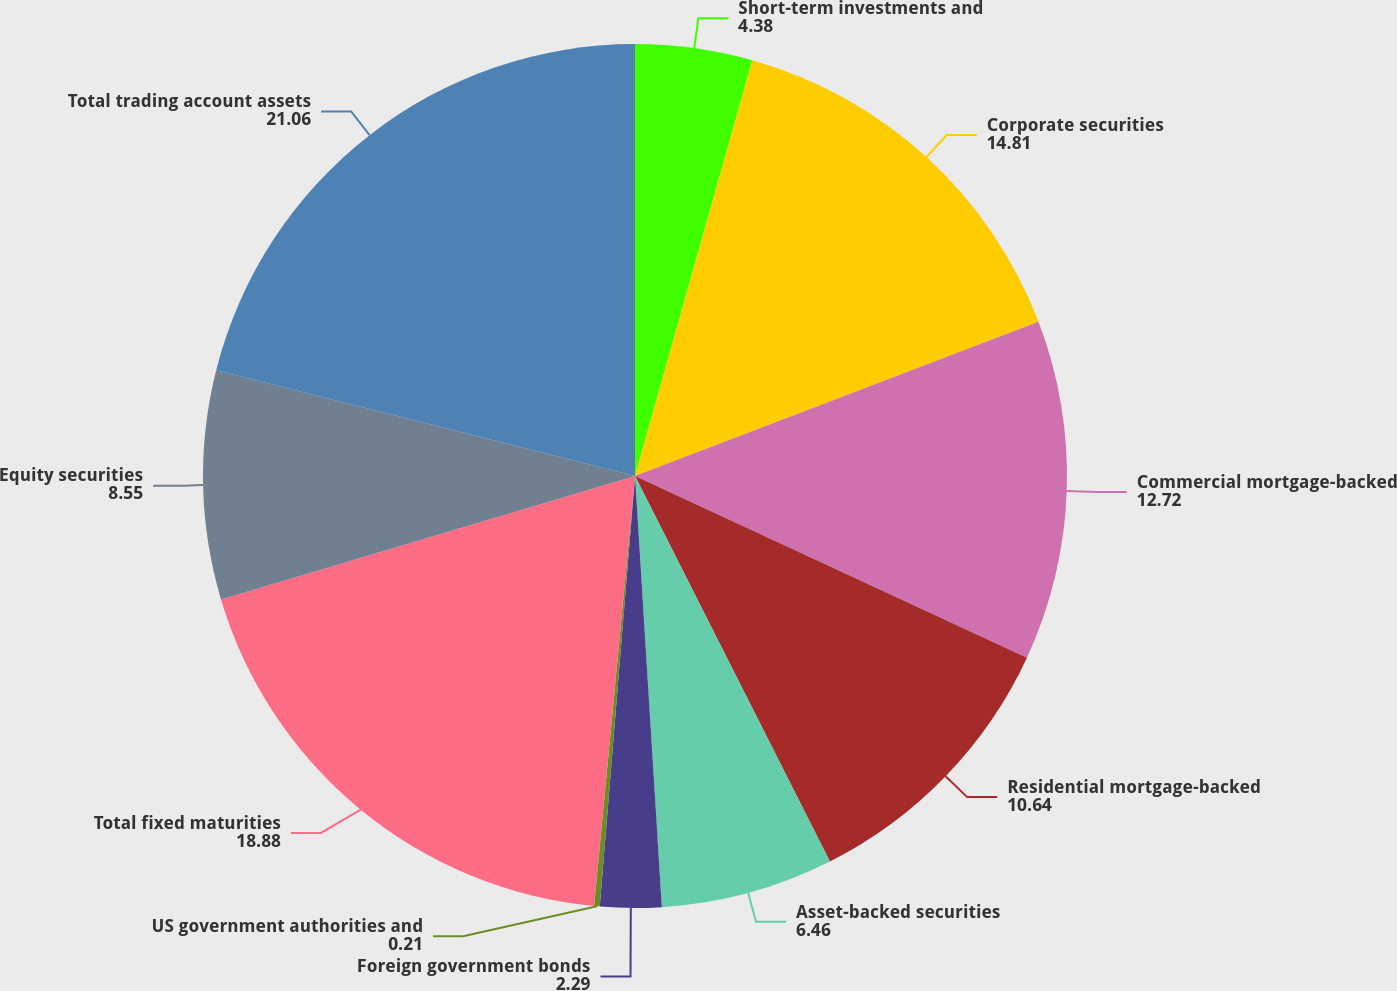Convert chart to OTSL. <chart><loc_0><loc_0><loc_500><loc_500><pie_chart><fcel>Short-term investments and<fcel>Corporate securities<fcel>Commercial mortgage-backed<fcel>Residential mortgage-backed<fcel>Asset-backed securities<fcel>Foreign government bonds<fcel>US government authorities and<fcel>Total fixed maturities<fcel>Equity securities<fcel>Total trading account assets<nl><fcel>4.38%<fcel>14.81%<fcel>12.72%<fcel>10.64%<fcel>6.46%<fcel>2.29%<fcel>0.21%<fcel>18.88%<fcel>8.55%<fcel>21.06%<nl></chart> 